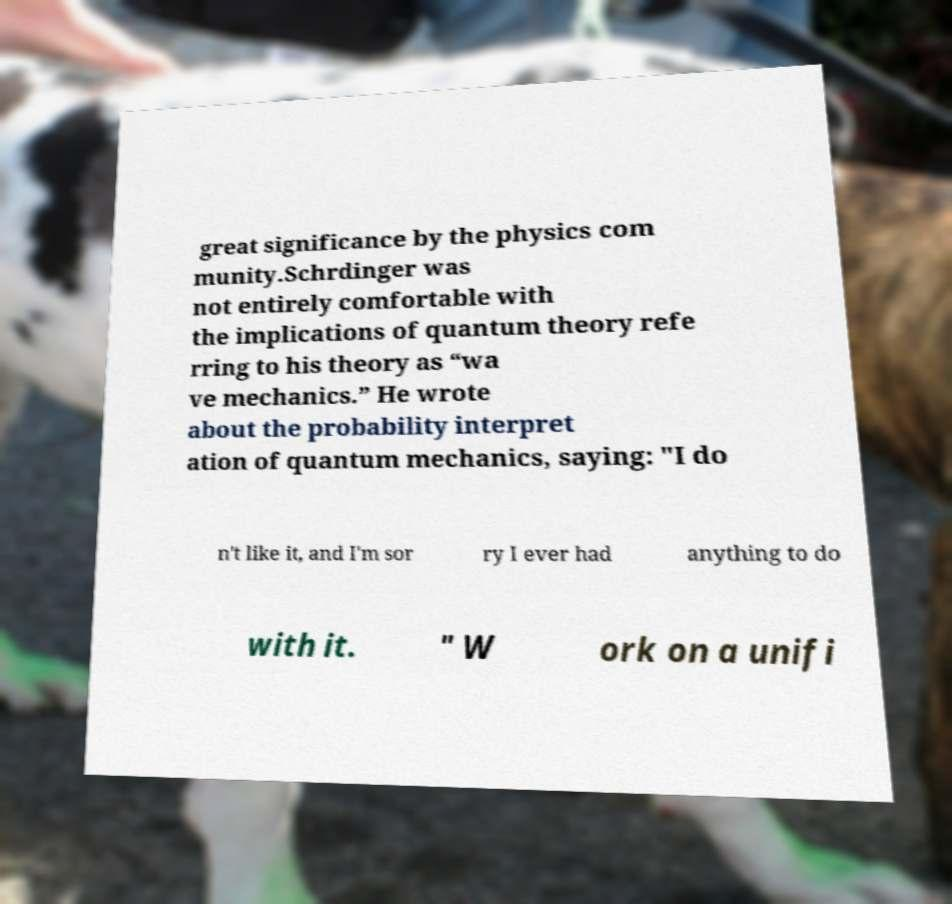I need the written content from this picture converted into text. Can you do that? great significance by the physics com munity.Schrdinger was not entirely comfortable with the implications of quantum theory refe rring to his theory as “wa ve mechanics.” He wrote about the probability interpret ation of quantum mechanics, saying: "I do n't like it, and I'm sor ry I ever had anything to do with it. " W ork on a unifi 